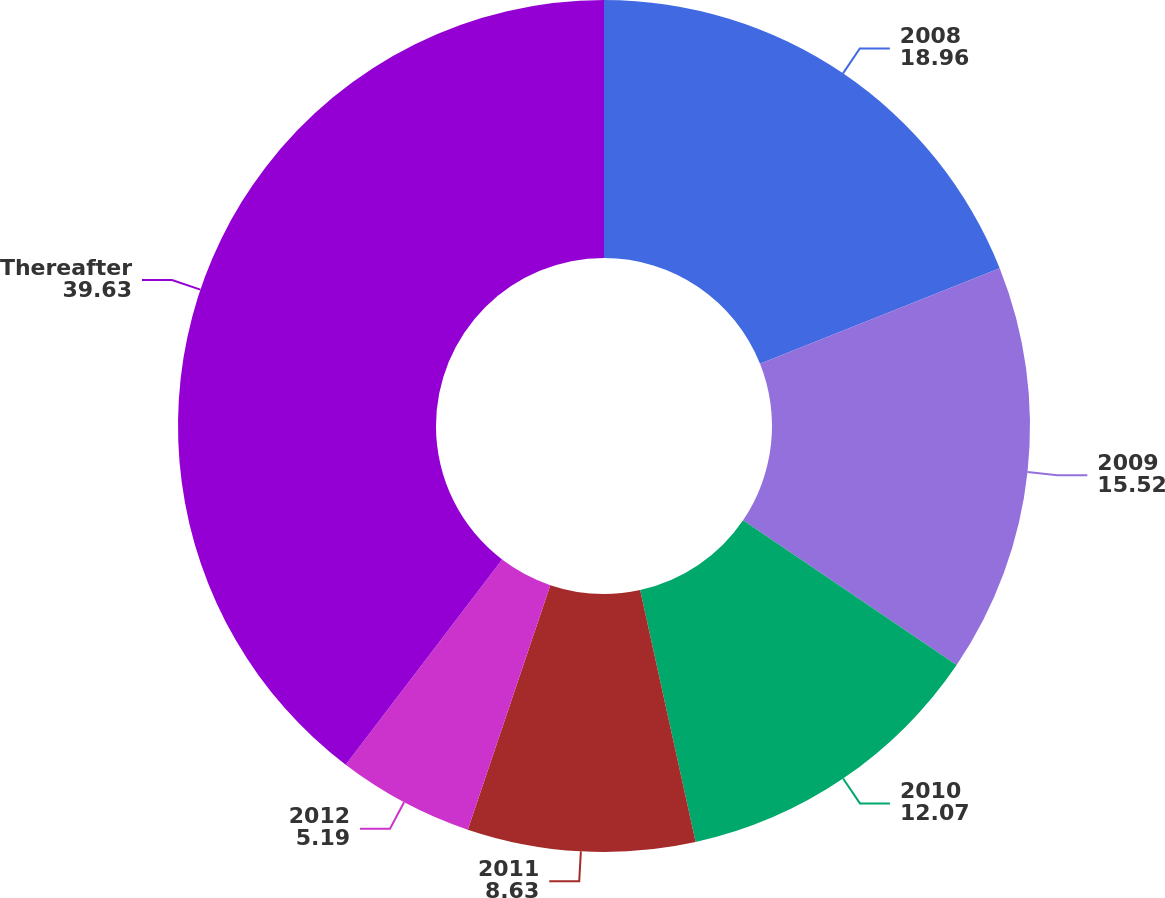Convert chart to OTSL. <chart><loc_0><loc_0><loc_500><loc_500><pie_chart><fcel>2008<fcel>2009<fcel>2010<fcel>2011<fcel>2012<fcel>Thereafter<nl><fcel>18.96%<fcel>15.52%<fcel>12.07%<fcel>8.63%<fcel>5.19%<fcel>39.63%<nl></chart> 